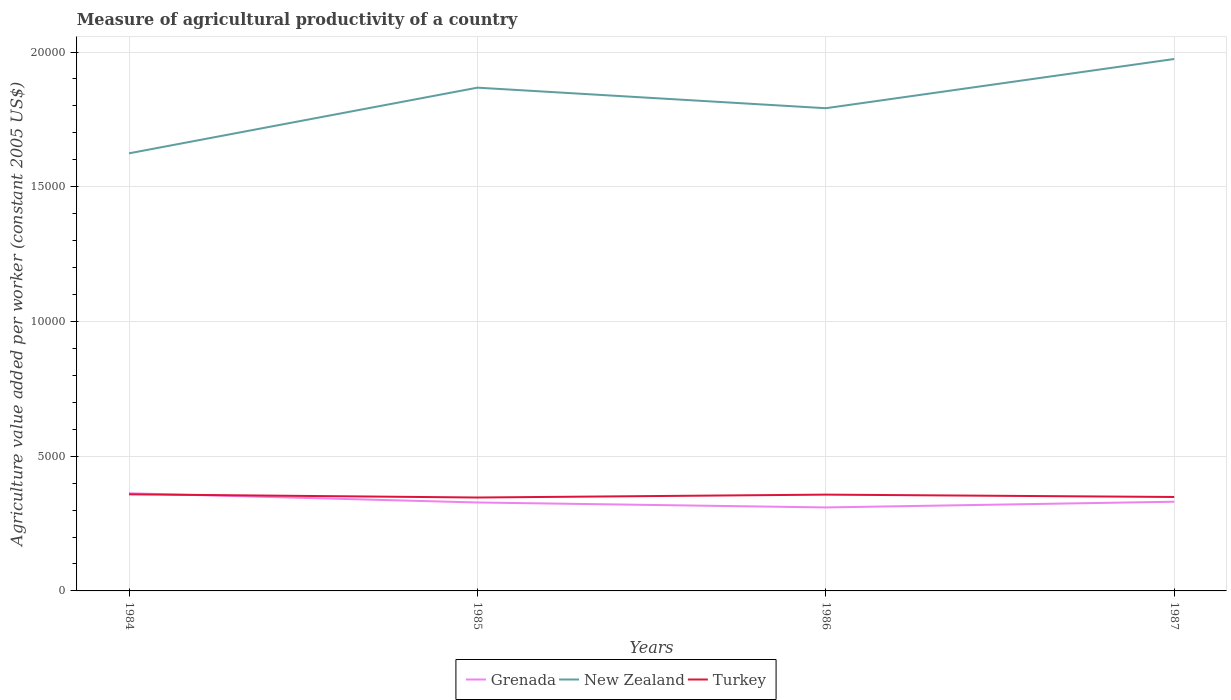Does the line corresponding to Grenada intersect with the line corresponding to Turkey?
Keep it short and to the point. Yes. Is the number of lines equal to the number of legend labels?
Provide a succinct answer. Yes. Across all years, what is the maximum measure of agricultural productivity in Grenada?
Your answer should be compact. 3098.39. What is the total measure of agricultural productivity in New Zealand in the graph?
Make the answer very short. -1826.57. What is the difference between the highest and the second highest measure of agricultural productivity in Turkey?
Your response must be concise. 118.74. What is the difference between the highest and the lowest measure of agricultural productivity in New Zealand?
Offer a terse response. 2. Is the measure of agricultural productivity in Turkey strictly greater than the measure of agricultural productivity in Grenada over the years?
Your answer should be very brief. No. How many years are there in the graph?
Provide a succinct answer. 4. What is the difference between two consecutive major ticks on the Y-axis?
Make the answer very short. 5000. Are the values on the major ticks of Y-axis written in scientific E-notation?
Give a very brief answer. No. Does the graph contain any zero values?
Ensure brevity in your answer.  No. Does the graph contain grids?
Ensure brevity in your answer.  Yes. What is the title of the graph?
Provide a short and direct response. Measure of agricultural productivity of a country. What is the label or title of the Y-axis?
Provide a succinct answer. Agriculture value added per worker (constant 2005 US$). What is the Agriculture value added per worker (constant 2005 US$) in Grenada in 1984?
Your answer should be very brief. 3624.8. What is the Agriculture value added per worker (constant 2005 US$) in New Zealand in 1984?
Provide a succinct answer. 1.62e+04. What is the Agriculture value added per worker (constant 2005 US$) of Turkey in 1984?
Provide a short and direct response. 3585.33. What is the Agriculture value added per worker (constant 2005 US$) of Grenada in 1985?
Offer a very short reply. 3281.91. What is the Agriculture value added per worker (constant 2005 US$) of New Zealand in 1985?
Keep it short and to the point. 1.87e+04. What is the Agriculture value added per worker (constant 2005 US$) of Turkey in 1985?
Your answer should be very brief. 3466.6. What is the Agriculture value added per worker (constant 2005 US$) in Grenada in 1986?
Your response must be concise. 3098.39. What is the Agriculture value added per worker (constant 2005 US$) of New Zealand in 1986?
Offer a very short reply. 1.79e+04. What is the Agriculture value added per worker (constant 2005 US$) in Turkey in 1986?
Provide a succinct answer. 3573.53. What is the Agriculture value added per worker (constant 2005 US$) in Grenada in 1987?
Offer a very short reply. 3310.35. What is the Agriculture value added per worker (constant 2005 US$) of New Zealand in 1987?
Your response must be concise. 1.97e+04. What is the Agriculture value added per worker (constant 2005 US$) of Turkey in 1987?
Provide a short and direct response. 3486.27. Across all years, what is the maximum Agriculture value added per worker (constant 2005 US$) in Grenada?
Give a very brief answer. 3624.8. Across all years, what is the maximum Agriculture value added per worker (constant 2005 US$) in New Zealand?
Offer a very short reply. 1.97e+04. Across all years, what is the maximum Agriculture value added per worker (constant 2005 US$) of Turkey?
Your answer should be very brief. 3585.33. Across all years, what is the minimum Agriculture value added per worker (constant 2005 US$) of Grenada?
Make the answer very short. 3098.39. Across all years, what is the minimum Agriculture value added per worker (constant 2005 US$) of New Zealand?
Make the answer very short. 1.62e+04. Across all years, what is the minimum Agriculture value added per worker (constant 2005 US$) of Turkey?
Your response must be concise. 3466.6. What is the total Agriculture value added per worker (constant 2005 US$) in Grenada in the graph?
Your response must be concise. 1.33e+04. What is the total Agriculture value added per worker (constant 2005 US$) of New Zealand in the graph?
Make the answer very short. 7.26e+04. What is the total Agriculture value added per worker (constant 2005 US$) in Turkey in the graph?
Make the answer very short. 1.41e+04. What is the difference between the Agriculture value added per worker (constant 2005 US$) in Grenada in 1984 and that in 1985?
Provide a succinct answer. 342.89. What is the difference between the Agriculture value added per worker (constant 2005 US$) in New Zealand in 1984 and that in 1985?
Your answer should be compact. -2437.1. What is the difference between the Agriculture value added per worker (constant 2005 US$) of Turkey in 1984 and that in 1985?
Provide a short and direct response. 118.74. What is the difference between the Agriculture value added per worker (constant 2005 US$) of Grenada in 1984 and that in 1986?
Provide a succinct answer. 526.41. What is the difference between the Agriculture value added per worker (constant 2005 US$) in New Zealand in 1984 and that in 1986?
Give a very brief answer. -1674.06. What is the difference between the Agriculture value added per worker (constant 2005 US$) in Turkey in 1984 and that in 1986?
Your answer should be compact. 11.8. What is the difference between the Agriculture value added per worker (constant 2005 US$) of Grenada in 1984 and that in 1987?
Offer a terse response. 314.45. What is the difference between the Agriculture value added per worker (constant 2005 US$) of New Zealand in 1984 and that in 1987?
Provide a short and direct response. -3500.64. What is the difference between the Agriculture value added per worker (constant 2005 US$) in Turkey in 1984 and that in 1987?
Your answer should be compact. 99.07. What is the difference between the Agriculture value added per worker (constant 2005 US$) of Grenada in 1985 and that in 1986?
Make the answer very short. 183.52. What is the difference between the Agriculture value added per worker (constant 2005 US$) in New Zealand in 1985 and that in 1986?
Make the answer very short. 763.03. What is the difference between the Agriculture value added per worker (constant 2005 US$) in Turkey in 1985 and that in 1986?
Keep it short and to the point. -106.93. What is the difference between the Agriculture value added per worker (constant 2005 US$) of Grenada in 1985 and that in 1987?
Your answer should be very brief. -28.44. What is the difference between the Agriculture value added per worker (constant 2005 US$) of New Zealand in 1985 and that in 1987?
Offer a terse response. -1063.54. What is the difference between the Agriculture value added per worker (constant 2005 US$) of Turkey in 1985 and that in 1987?
Your answer should be compact. -19.67. What is the difference between the Agriculture value added per worker (constant 2005 US$) of Grenada in 1986 and that in 1987?
Your response must be concise. -211.96. What is the difference between the Agriculture value added per worker (constant 2005 US$) in New Zealand in 1986 and that in 1987?
Your response must be concise. -1826.57. What is the difference between the Agriculture value added per worker (constant 2005 US$) in Turkey in 1986 and that in 1987?
Your answer should be compact. 87.27. What is the difference between the Agriculture value added per worker (constant 2005 US$) of Grenada in 1984 and the Agriculture value added per worker (constant 2005 US$) of New Zealand in 1985?
Your answer should be compact. -1.51e+04. What is the difference between the Agriculture value added per worker (constant 2005 US$) in Grenada in 1984 and the Agriculture value added per worker (constant 2005 US$) in Turkey in 1985?
Provide a short and direct response. 158.2. What is the difference between the Agriculture value added per worker (constant 2005 US$) in New Zealand in 1984 and the Agriculture value added per worker (constant 2005 US$) in Turkey in 1985?
Offer a terse response. 1.28e+04. What is the difference between the Agriculture value added per worker (constant 2005 US$) in Grenada in 1984 and the Agriculture value added per worker (constant 2005 US$) in New Zealand in 1986?
Your answer should be compact. -1.43e+04. What is the difference between the Agriculture value added per worker (constant 2005 US$) in Grenada in 1984 and the Agriculture value added per worker (constant 2005 US$) in Turkey in 1986?
Your answer should be very brief. 51.27. What is the difference between the Agriculture value added per worker (constant 2005 US$) in New Zealand in 1984 and the Agriculture value added per worker (constant 2005 US$) in Turkey in 1986?
Make the answer very short. 1.27e+04. What is the difference between the Agriculture value added per worker (constant 2005 US$) in Grenada in 1984 and the Agriculture value added per worker (constant 2005 US$) in New Zealand in 1987?
Make the answer very short. -1.61e+04. What is the difference between the Agriculture value added per worker (constant 2005 US$) in Grenada in 1984 and the Agriculture value added per worker (constant 2005 US$) in Turkey in 1987?
Your answer should be very brief. 138.53. What is the difference between the Agriculture value added per worker (constant 2005 US$) in New Zealand in 1984 and the Agriculture value added per worker (constant 2005 US$) in Turkey in 1987?
Offer a terse response. 1.28e+04. What is the difference between the Agriculture value added per worker (constant 2005 US$) in Grenada in 1985 and the Agriculture value added per worker (constant 2005 US$) in New Zealand in 1986?
Give a very brief answer. -1.46e+04. What is the difference between the Agriculture value added per worker (constant 2005 US$) of Grenada in 1985 and the Agriculture value added per worker (constant 2005 US$) of Turkey in 1986?
Give a very brief answer. -291.63. What is the difference between the Agriculture value added per worker (constant 2005 US$) of New Zealand in 1985 and the Agriculture value added per worker (constant 2005 US$) of Turkey in 1986?
Your response must be concise. 1.51e+04. What is the difference between the Agriculture value added per worker (constant 2005 US$) of Grenada in 1985 and the Agriculture value added per worker (constant 2005 US$) of New Zealand in 1987?
Offer a terse response. -1.65e+04. What is the difference between the Agriculture value added per worker (constant 2005 US$) of Grenada in 1985 and the Agriculture value added per worker (constant 2005 US$) of Turkey in 1987?
Your response must be concise. -204.36. What is the difference between the Agriculture value added per worker (constant 2005 US$) of New Zealand in 1985 and the Agriculture value added per worker (constant 2005 US$) of Turkey in 1987?
Ensure brevity in your answer.  1.52e+04. What is the difference between the Agriculture value added per worker (constant 2005 US$) of Grenada in 1986 and the Agriculture value added per worker (constant 2005 US$) of New Zealand in 1987?
Provide a succinct answer. -1.66e+04. What is the difference between the Agriculture value added per worker (constant 2005 US$) of Grenada in 1986 and the Agriculture value added per worker (constant 2005 US$) of Turkey in 1987?
Provide a succinct answer. -387.88. What is the difference between the Agriculture value added per worker (constant 2005 US$) in New Zealand in 1986 and the Agriculture value added per worker (constant 2005 US$) in Turkey in 1987?
Provide a succinct answer. 1.44e+04. What is the average Agriculture value added per worker (constant 2005 US$) of Grenada per year?
Your answer should be compact. 3328.86. What is the average Agriculture value added per worker (constant 2005 US$) in New Zealand per year?
Provide a short and direct response. 1.81e+04. What is the average Agriculture value added per worker (constant 2005 US$) of Turkey per year?
Keep it short and to the point. 3527.93. In the year 1984, what is the difference between the Agriculture value added per worker (constant 2005 US$) of Grenada and Agriculture value added per worker (constant 2005 US$) of New Zealand?
Provide a succinct answer. -1.26e+04. In the year 1984, what is the difference between the Agriculture value added per worker (constant 2005 US$) in Grenada and Agriculture value added per worker (constant 2005 US$) in Turkey?
Offer a terse response. 39.47. In the year 1984, what is the difference between the Agriculture value added per worker (constant 2005 US$) of New Zealand and Agriculture value added per worker (constant 2005 US$) of Turkey?
Your response must be concise. 1.27e+04. In the year 1985, what is the difference between the Agriculture value added per worker (constant 2005 US$) of Grenada and Agriculture value added per worker (constant 2005 US$) of New Zealand?
Keep it short and to the point. -1.54e+04. In the year 1985, what is the difference between the Agriculture value added per worker (constant 2005 US$) in Grenada and Agriculture value added per worker (constant 2005 US$) in Turkey?
Keep it short and to the point. -184.69. In the year 1985, what is the difference between the Agriculture value added per worker (constant 2005 US$) of New Zealand and Agriculture value added per worker (constant 2005 US$) of Turkey?
Keep it short and to the point. 1.52e+04. In the year 1986, what is the difference between the Agriculture value added per worker (constant 2005 US$) in Grenada and Agriculture value added per worker (constant 2005 US$) in New Zealand?
Keep it short and to the point. -1.48e+04. In the year 1986, what is the difference between the Agriculture value added per worker (constant 2005 US$) of Grenada and Agriculture value added per worker (constant 2005 US$) of Turkey?
Offer a terse response. -475.14. In the year 1986, what is the difference between the Agriculture value added per worker (constant 2005 US$) in New Zealand and Agriculture value added per worker (constant 2005 US$) in Turkey?
Make the answer very short. 1.43e+04. In the year 1987, what is the difference between the Agriculture value added per worker (constant 2005 US$) in Grenada and Agriculture value added per worker (constant 2005 US$) in New Zealand?
Offer a very short reply. -1.64e+04. In the year 1987, what is the difference between the Agriculture value added per worker (constant 2005 US$) in Grenada and Agriculture value added per worker (constant 2005 US$) in Turkey?
Your answer should be compact. -175.92. In the year 1987, what is the difference between the Agriculture value added per worker (constant 2005 US$) in New Zealand and Agriculture value added per worker (constant 2005 US$) in Turkey?
Make the answer very short. 1.63e+04. What is the ratio of the Agriculture value added per worker (constant 2005 US$) in Grenada in 1984 to that in 1985?
Make the answer very short. 1.1. What is the ratio of the Agriculture value added per worker (constant 2005 US$) of New Zealand in 1984 to that in 1985?
Make the answer very short. 0.87. What is the ratio of the Agriculture value added per worker (constant 2005 US$) of Turkey in 1984 to that in 1985?
Provide a short and direct response. 1.03. What is the ratio of the Agriculture value added per worker (constant 2005 US$) in Grenada in 1984 to that in 1986?
Provide a succinct answer. 1.17. What is the ratio of the Agriculture value added per worker (constant 2005 US$) of New Zealand in 1984 to that in 1986?
Your answer should be very brief. 0.91. What is the ratio of the Agriculture value added per worker (constant 2005 US$) of Turkey in 1984 to that in 1986?
Offer a very short reply. 1. What is the ratio of the Agriculture value added per worker (constant 2005 US$) in Grenada in 1984 to that in 1987?
Ensure brevity in your answer.  1.09. What is the ratio of the Agriculture value added per worker (constant 2005 US$) in New Zealand in 1984 to that in 1987?
Provide a succinct answer. 0.82. What is the ratio of the Agriculture value added per worker (constant 2005 US$) in Turkey in 1984 to that in 1987?
Your answer should be very brief. 1.03. What is the ratio of the Agriculture value added per worker (constant 2005 US$) of Grenada in 1985 to that in 1986?
Give a very brief answer. 1.06. What is the ratio of the Agriculture value added per worker (constant 2005 US$) in New Zealand in 1985 to that in 1986?
Provide a succinct answer. 1.04. What is the ratio of the Agriculture value added per worker (constant 2005 US$) of Turkey in 1985 to that in 1986?
Provide a succinct answer. 0.97. What is the ratio of the Agriculture value added per worker (constant 2005 US$) in Grenada in 1985 to that in 1987?
Offer a terse response. 0.99. What is the ratio of the Agriculture value added per worker (constant 2005 US$) in New Zealand in 1985 to that in 1987?
Your response must be concise. 0.95. What is the ratio of the Agriculture value added per worker (constant 2005 US$) of Turkey in 1985 to that in 1987?
Offer a terse response. 0.99. What is the ratio of the Agriculture value added per worker (constant 2005 US$) in Grenada in 1986 to that in 1987?
Provide a short and direct response. 0.94. What is the ratio of the Agriculture value added per worker (constant 2005 US$) of New Zealand in 1986 to that in 1987?
Offer a very short reply. 0.91. What is the difference between the highest and the second highest Agriculture value added per worker (constant 2005 US$) in Grenada?
Your answer should be compact. 314.45. What is the difference between the highest and the second highest Agriculture value added per worker (constant 2005 US$) in New Zealand?
Provide a succinct answer. 1063.54. What is the difference between the highest and the second highest Agriculture value added per worker (constant 2005 US$) in Turkey?
Keep it short and to the point. 11.8. What is the difference between the highest and the lowest Agriculture value added per worker (constant 2005 US$) in Grenada?
Give a very brief answer. 526.41. What is the difference between the highest and the lowest Agriculture value added per worker (constant 2005 US$) of New Zealand?
Ensure brevity in your answer.  3500.64. What is the difference between the highest and the lowest Agriculture value added per worker (constant 2005 US$) of Turkey?
Offer a very short reply. 118.74. 